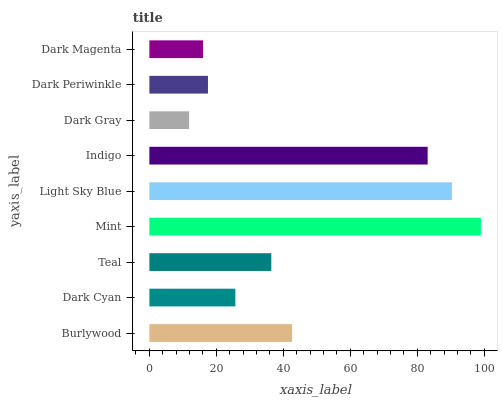Is Dark Gray the minimum?
Answer yes or no. Yes. Is Mint the maximum?
Answer yes or no. Yes. Is Dark Cyan the minimum?
Answer yes or no. No. Is Dark Cyan the maximum?
Answer yes or no. No. Is Burlywood greater than Dark Cyan?
Answer yes or no. Yes. Is Dark Cyan less than Burlywood?
Answer yes or no. Yes. Is Dark Cyan greater than Burlywood?
Answer yes or no. No. Is Burlywood less than Dark Cyan?
Answer yes or no. No. Is Teal the high median?
Answer yes or no. Yes. Is Teal the low median?
Answer yes or no. Yes. Is Indigo the high median?
Answer yes or no. No. Is Mint the low median?
Answer yes or no. No. 